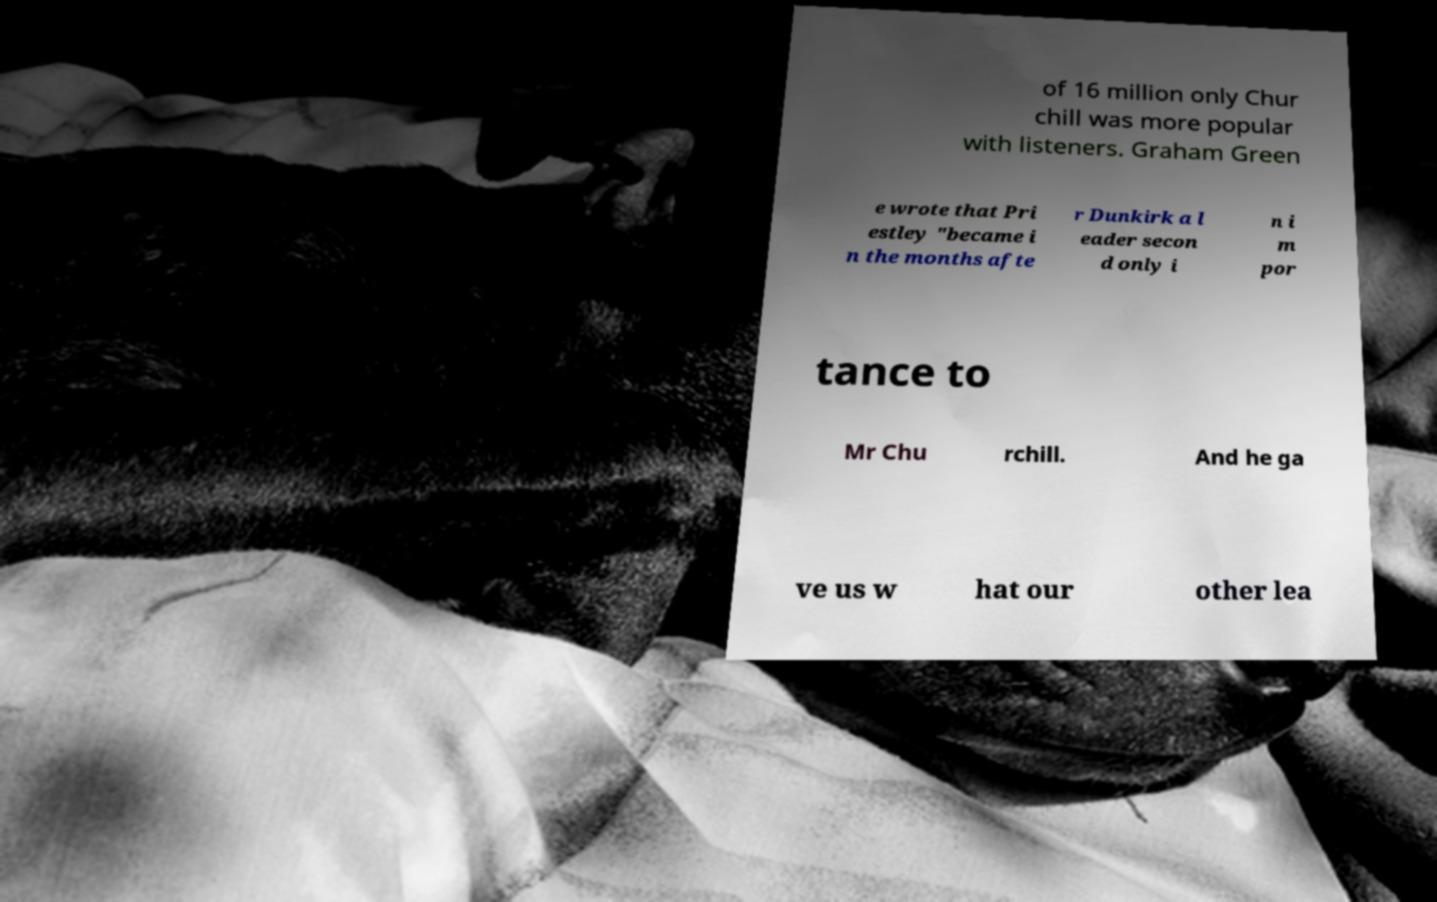Can you accurately transcribe the text from the provided image for me? of 16 million only Chur chill was more popular with listeners. Graham Green e wrote that Pri estley "became i n the months afte r Dunkirk a l eader secon d only i n i m por tance to Mr Chu rchill. And he ga ve us w hat our other lea 